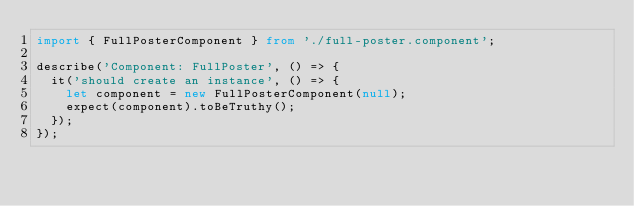Convert code to text. <code><loc_0><loc_0><loc_500><loc_500><_TypeScript_>import { FullPosterComponent } from './full-poster.component';

describe('Component: FullPoster', () => {
  it('should create an instance', () => {
    let component = new FullPosterComponent(null);
    expect(component).toBeTruthy();
  });
});
</code> 